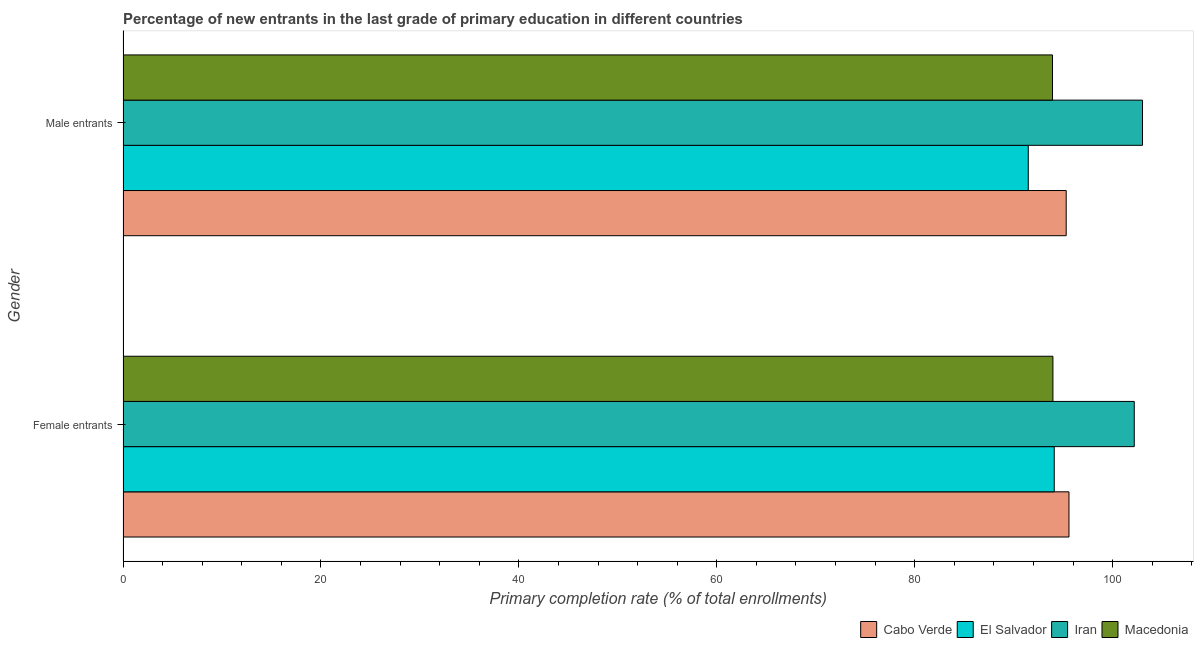How many different coloured bars are there?
Provide a short and direct response. 4. How many groups of bars are there?
Give a very brief answer. 2. Are the number of bars per tick equal to the number of legend labels?
Your response must be concise. Yes. How many bars are there on the 2nd tick from the top?
Provide a short and direct response. 4. What is the label of the 2nd group of bars from the top?
Provide a succinct answer. Female entrants. What is the primary completion rate of female entrants in Macedonia?
Offer a very short reply. 93.97. Across all countries, what is the maximum primary completion rate of male entrants?
Keep it short and to the point. 103.02. Across all countries, what is the minimum primary completion rate of female entrants?
Ensure brevity in your answer.  93.97. In which country was the primary completion rate of female entrants maximum?
Ensure brevity in your answer.  Iran. In which country was the primary completion rate of male entrants minimum?
Your response must be concise. El Salvador. What is the total primary completion rate of female entrants in the graph?
Provide a short and direct response. 385.85. What is the difference between the primary completion rate of male entrants in Macedonia and that in El Salvador?
Keep it short and to the point. 2.45. What is the difference between the primary completion rate of female entrants in Cabo Verde and the primary completion rate of male entrants in Macedonia?
Offer a terse response. 1.66. What is the average primary completion rate of male entrants per country?
Your response must be concise. 95.93. What is the difference between the primary completion rate of male entrants and primary completion rate of female entrants in El Salvador?
Make the answer very short. -2.62. In how many countries, is the primary completion rate of female entrants greater than 48 %?
Offer a very short reply. 4. What is the ratio of the primary completion rate of male entrants in Macedonia to that in El Salvador?
Give a very brief answer. 1.03. Is the primary completion rate of female entrants in Iran less than that in El Salvador?
Provide a succinct answer. No. In how many countries, is the primary completion rate of male entrants greater than the average primary completion rate of male entrants taken over all countries?
Keep it short and to the point. 1. What does the 2nd bar from the top in Male entrants represents?
Give a very brief answer. Iran. What does the 1st bar from the bottom in Female entrants represents?
Your answer should be compact. Cabo Verde. Does the graph contain any zero values?
Provide a succinct answer. No. Where does the legend appear in the graph?
Keep it short and to the point. Bottom right. What is the title of the graph?
Give a very brief answer. Percentage of new entrants in the last grade of primary education in different countries. What is the label or title of the X-axis?
Provide a succinct answer. Primary completion rate (% of total enrollments). What is the Primary completion rate (% of total enrollments) of Cabo Verde in Female entrants?
Your response must be concise. 95.59. What is the Primary completion rate (% of total enrollments) of El Salvador in Female entrants?
Your response must be concise. 94.1. What is the Primary completion rate (% of total enrollments) in Iran in Female entrants?
Offer a very short reply. 102.19. What is the Primary completion rate (% of total enrollments) of Macedonia in Female entrants?
Keep it short and to the point. 93.97. What is the Primary completion rate (% of total enrollments) in Cabo Verde in Male entrants?
Make the answer very short. 95.31. What is the Primary completion rate (% of total enrollments) of El Salvador in Male entrants?
Ensure brevity in your answer.  91.48. What is the Primary completion rate (% of total enrollments) of Iran in Male entrants?
Give a very brief answer. 103.02. What is the Primary completion rate (% of total enrollments) of Macedonia in Male entrants?
Offer a terse response. 93.93. Across all Gender, what is the maximum Primary completion rate (% of total enrollments) of Cabo Verde?
Your answer should be very brief. 95.59. Across all Gender, what is the maximum Primary completion rate (% of total enrollments) of El Salvador?
Keep it short and to the point. 94.1. Across all Gender, what is the maximum Primary completion rate (% of total enrollments) of Iran?
Your answer should be very brief. 103.02. Across all Gender, what is the maximum Primary completion rate (% of total enrollments) of Macedonia?
Your response must be concise. 93.97. Across all Gender, what is the minimum Primary completion rate (% of total enrollments) of Cabo Verde?
Your answer should be compact. 95.31. Across all Gender, what is the minimum Primary completion rate (% of total enrollments) of El Salvador?
Provide a succinct answer. 91.48. Across all Gender, what is the minimum Primary completion rate (% of total enrollments) in Iran?
Keep it short and to the point. 102.19. Across all Gender, what is the minimum Primary completion rate (% of total enrollments) of Macedonia?
Your answer should be very brief. 93.93. What is the total Primary completion rate (% of total enrollments) of Cabo Verde in the graph?
Make the answer very short. 190.9. What is the total Primary completion rate (% of total enrollments) of El Salvador in the graph?
Keep it short and to the point. 185.58. What is the total Primary completion rate (% of total enrollments) in Iran in the graph?
Your response must be concise. 205.21. What is the total Primary completion rate (% of total enrollments) in Macedonia in the graph?
Your answer should be very brief. 187.9. What is the difference between the Primary completion rate (% of total enrollments) of Cabo Verde in Female entrants and that in Male entrants?
Keep it short and to the point. 0.28. What is the difference between the Primary completion rate (% of total enrollments) of El Salvador in Female entrants and that in Male entrants?
Make the answer very short. 2.62. What is the difference between the Primary completion rate (% of total enrollments) of Iran in Female entrants and that in Male entrants?
Give a very brief answer. -0.83. What is the difference between the Primary completion rate (% of total enrollments) in Macedonia in Female entrants and that in Male entrants?
Provide a succinct answer. 0.04. What is the difference between the Primary completion rate (% of total enrollments) in Cabo Verde in Female entrants and the Primary completion rate (% of total enrollments) in El Salvador in Male entrants?
Your answer should be compact. 4.11. What is the difference between the Primary completion rate (% of total enrollments) in Cabo Verde in Female entrants and the Primary completion rate (% of total enrollments) in Iran in Male entrants?
Your response must be concise. -7.43. What is the difference between the Primary completion rate (% of total enrollments) in Cabo Verde in Female entrants and the Primary completion rate (% of total enrollments) in Macedonia in Male entrants?
Provide a short and direct response. 1.66. What is the difference between the Primary completion rate (% of total enrollments) of El Salvador in Female entrants and the Primary completion rate (% of total enrollments) of Iran in Male entrants?
Your response must be concise. -8.92. What is the difference between the Primary completion rate (% of total enrollments) of El Salvador in Female entrants and the Primary completion rate (% of total enrollments) of Macedonia in Male entrants?
Your answer should be very brief. 0.17. What is the difference between the Primary completion rate (% of total enrollments) in Iran in Female entrants and the Primary completion rate (% of total enrollments) in Macedonia in Male entrants?
Ensure brevity in your answer.  8.26. What is the average Primary completion rate (% of total enrollments) of Cabo Verde per Gender?
Provide a succinct answer. 95.45. What is the average Primary completion rate (% of total enrollments) of El Salvador per Gender?
Make the answer very short. 92.79. What is the average Primary completion rate (% of total enrollments) in Iran per Gender?
Give a very brief answer. 102.6. What is the average Primary completion rate (% of total enrollments) in Macedonia per Gender?
Ensure brevity in your answer.  93.95. What is the difference between the Primary completion rate (% of total enrollments) of Cabo Verde and Primary completion rate (% of total enrollments) of El Salvador in Female entrants?
Ensure brevity in your answer.  1.49. What is the difference between the Primary completion rate (% of total enrollments) of Cabo Verde and Primary completion rate (% of total enrollments) of Iran in Female entrants?
Ensure brevity in your answer.  -6.6. What is the difference between the Primary completion rate (% of total enrollments) in Cabo Verde and Primary completion rate (% of total enrollments) in Macedonia in Female entrants?
Your answer should be compact. 1.62. What is the difference between the Primary completion rate (% of total enrollments) of El Salvador and Primary completion rate (% of total enrollments) of Iran in Female entrants?
Offer a terse response. -8.09. What is the difference between the Primary completion rate (% of total enrollments) of El Salvador and Primary completion rate (% of total enrollments) of Macedonia in Female entrants?
Keep it short and to the point. 0.13. What is the difference between the Primary completion rate (% of total enrollments) of Iran and Primary completion rate (% of total enrollments) of Macedonia in Female entrants?
Your response must be concise. 8.22. What is the difference between the Primary completion rate (% of total enrollments) in Cabo Verde and Primary completion rate (% of total enrollments) in El Salvador in Male entrants?
Keep it short and to the point. 3.83. What is the difference between the Primary completion rate (% of total enrollments) of Cabo Verde and Primary completion rate (% of total enrollments) of Iran in Male entrants?
Provide a short and direct response. -7.71. What is the difference between the Primary completion rate (% of total enrollments) of Cabo Verde and Primary completion rate (% of total enrollments) of Macedonia in Male entrants?
Your response must be concise. 1.38. What is the difference between the Primary completion rate (% of total enrollments) in El Salvador and Primary completion rate (% of total enrollments) in Iran in Male entrants?
Offer a very short reply. -11.55. What is the difference between the Primary completion rate (% of total enrollments) in El Salvador and Primary completion rate (% of total enrollments) in Macedonia in Male entrants?
Offer a very short reply. -2.45. What is the difference between the Primary completion rate (% of total enrollments) of Iran and Primary completion rate (% of total enrollments) of Macedonia in Male entrants?
Ensure brevity in your answer.  9.09. What is the ratio of the Primary completion rate (% of total enrollments) in El Salvador in Female entrants to that in Male entrants?
Give a very brief answer. 1.03. What is the ratio of the Primary completion rate (% of total enrollments) in Iran in Female entrants to that in Male entrants?
Ensure brevity in your answer.  0.99. What is the ratio of the Primary completion rate (% of total enrollments) in Macedonia in Female entrants to that in Male entrants?
Ensure brevity in your answer.  1. What is the difference between the highest and the second highest Primary completion rate (% of total enrollments) of Cabo Verde?
Keep it short and to the point. 0.28. What is the difference between the highest and the second highest Primary completion rate (% of total enrollments) in El Salvador?
Your answer should be very brief. 2.62. What is the difference between the highest and the second highest Primary completion rate (% of total enrollments) in Iran?
Your answer should be very brief. 0.83. What is the difference between the highest and the second highest Primary completion rate (% of total enrollments) of Macedonia?
Give a very brief answer. 0.04. What is the difference between the highest and the lowest Primary completion rate (% of total enrollments) in Cabo Verde?
Give a very brief answer. 0.28. What is the difference between the highest and the lowest Primary completion rate (% of total enrollments) of El Salvador?
Provide a short and direct response. 2.62. What is the difference between the highest and the lowest Primary completion rate (% of total enrollments) of Iran?
Keep it short and to the point. 0.83. What is the difference between the highest and the lowest Primary completion rate (% of total enrollments) of Macedonia?
Offer a terse response. 0.04. 